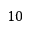Convert formula to latex. <formula><loc_0><loc_0><loc_500><loc_500>1 0</formula> 